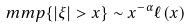Convert formula to latex. <formula><loc_0><loc_0><loc_500><loc_500>\ m m p \{ | \xi | > x \} \sim x ^ { - \alpha } \ell ( x )</formula> 